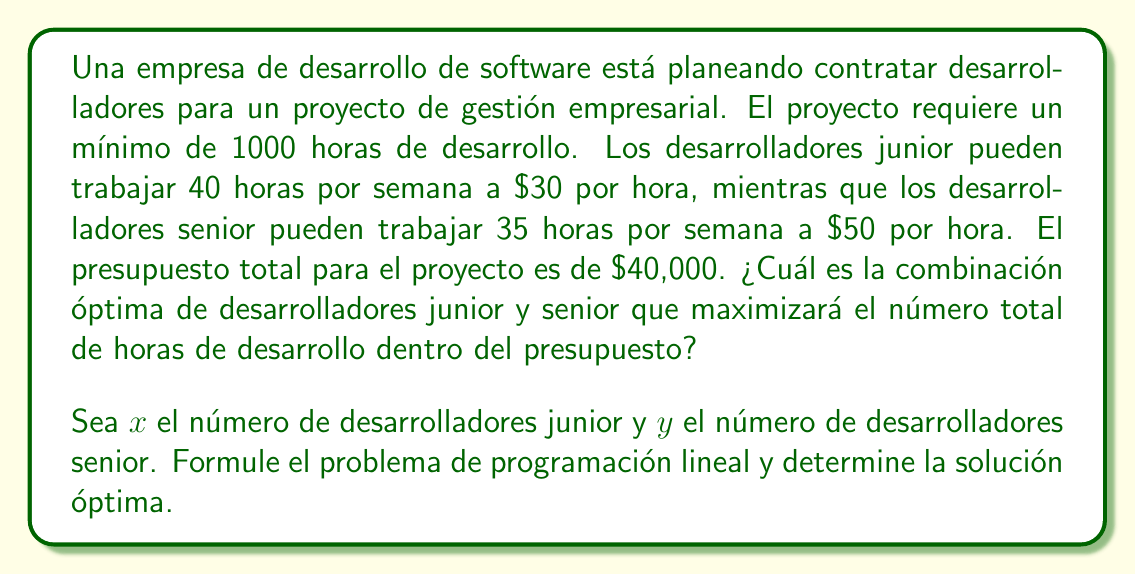Give your solution to this math problem. Para resolver este problema, seguiremos estos pasos:

1) Definir las variables de decisión:
   $x$ = número de desarrolladores junior
   $y$ = número de desarrolladores senior

2) Formular la función objetivo:
   Queremos maximizar las horas totales de desarrollo:
   $$\text{Maximizar } Z = 40x + 35y$$

3) Identificar las restricciones:
   a) Restricción de presupuesto:
      $$30 \cdot 40x + 50 \cdot 35y \leq 40000$$
      simplificando: $$1200x + 1750y \leq 40000$$

   b) Restricción de horas mínimas:
      $$40x + 35y \geq 1000$$

   c) Restricciones de no negatividad:
      $$x \geq 0, y \geq 0$$

4) El problema de programación lineal completo:
   $$\text{Maximizar } Z = 40x + 35y$$
   $$\text{Sujeto a:}$$
   $$1200x + 1750y \leq 40000$$
   $$40x + 35y \geq 1000$$
   $$x \geq 0, y \geq 0$$

5) Resolver gráficamente:
   Graficamos las restricciones y encontramos los puntos de intersección:

   [asy]
   import geometry;

   size(200);
   
   real xmax = 35;
   real ymax = 25;

   xaxis("x", 0, xmax, arrow=Arrow);
   yaxis("y", 0, ymax, arrow=Arrow);

   path budget = (0,22.86)--(33.33,0);
   path hours = (25,0)--(0,28.57);

   draw(budget, blue);
   draw(hours, red);

   dot((25,10), green);
   dot((22.86,11.43), green);

   label("(25,10)", (25,10), SE);
   label("(22.86,11.43)", (22.86,11.43), NW);

   [/asy]

6) Los puntos de intersección son (25,10) y (22.86,11.43).

7) Evaluamos la función objetivo en estos puntos:
   Para (25,10): Z = 40(25) + 35(10) = 1350
   Para (22.86,11.43): Z = 40(22.86) + 35(11.43) ≈ 1314

8) La solución óptima es el punto (25,10), que da el mayor valor de Z.
Answer: 25 desarrolladores junior y 10 desarrolladores senior. 